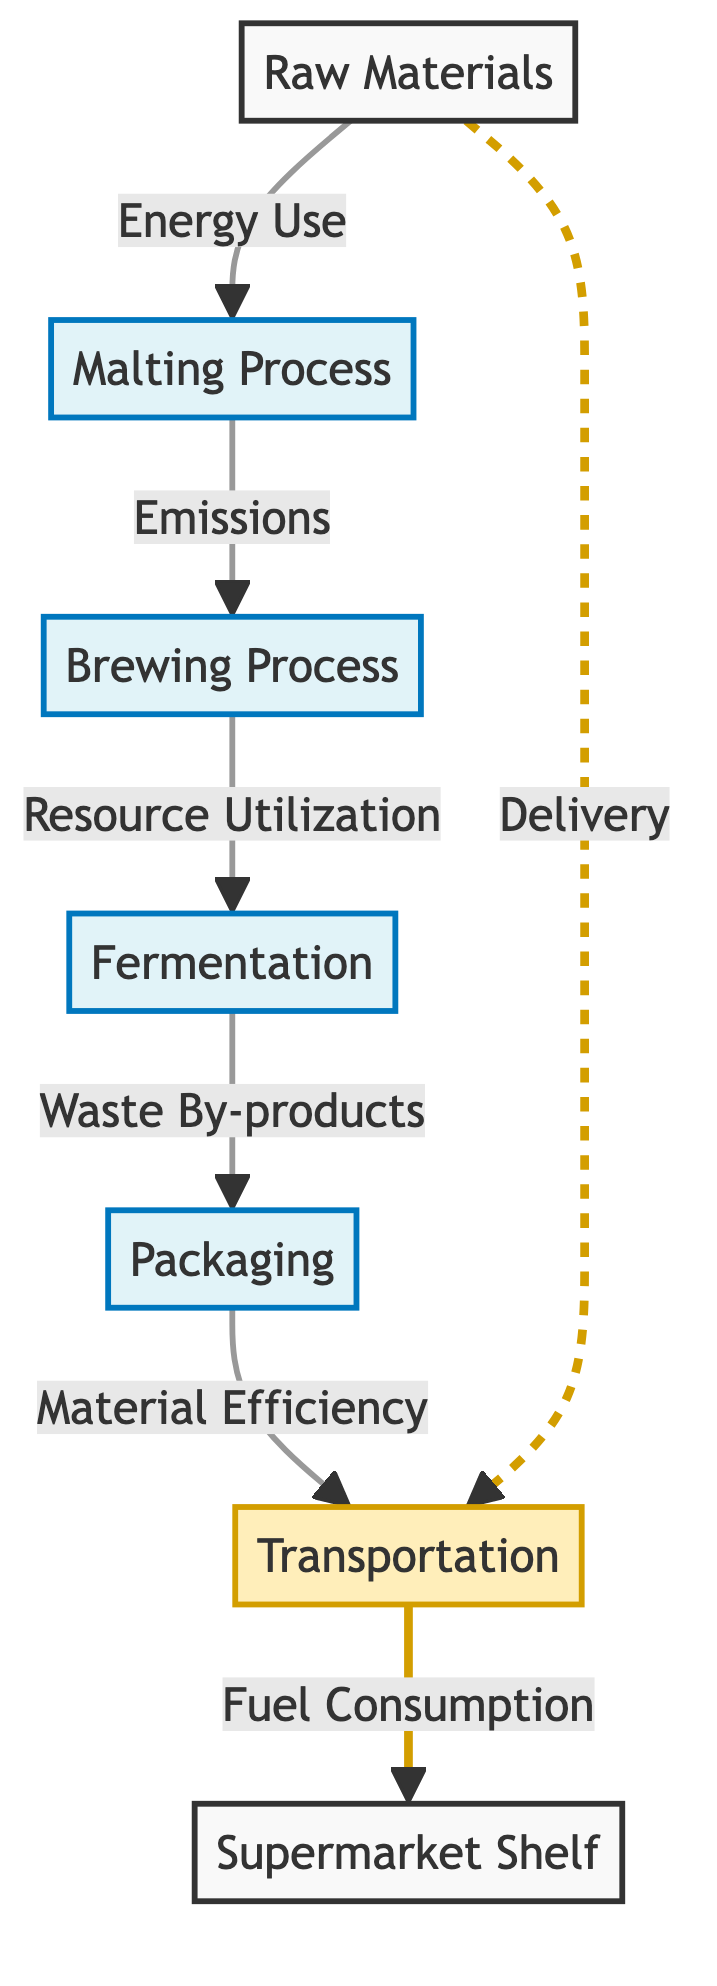What is the starting point of the process? The starting point is denoted by the node labeled "Raw Materials," which is the initial stage before any processing occurs.
Answer: Raw Materials How many distinct processes are involved in beer production? The diagram shows four distinct processes: Malting, Brewing, Fermentation, and Packaging, each represented by their own nodes.
Answer: Four What follows the brewing process? According to the flow of the diagram, the Brewing Process leads directly to the Fermentation stage.
Answer: Fermentation What does the packaging process improve in terms of production? The packaging process is associated with "Material Efficiency," indicating that it focuses on optimizing the use of materials during production.
Answer: Material Efficiency What is shown to be a waste result of fermentation? The diagram indicates that the Fermentation stage produces "Waste By-products," which are by-products that occur during this stage.
Answer: Waste By-products How is transportation linked to the raw materials stage? The diagram shows a dashed line connecting Raw Materials to Transportation, labeled as "Delivery," indicating that transportation is involved in delivering raw materials.
Answer: Delivery What is the final destination for the beer after transportation? The final destination in the flow of the diagram is represented by the node labeled "Supermarket Shelf," indicating where the beer ends up.
Answer: Supermarket Shelf What type of consumption is associated with transportation? The diagram states the link from Transportation to Supermarket Shelf is influenced by "Fuel Consumption," showing that energy use is a key factor in this stage.
Answer: Fuel Consumption Which process is indicated to utilize resources? The Brewing Process is labeled with "Resource Utilization," suggesting that it optimally uses resources during production.
Answer: Resource Utilization 